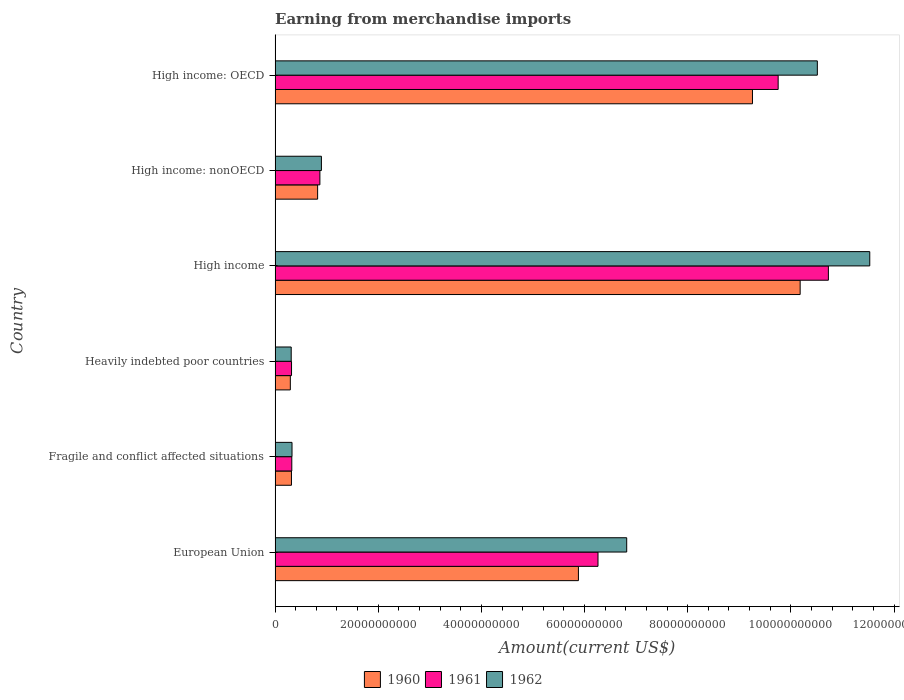How many groups of bars are there?
Give a very brief answer. 6. How many bars are there on the 4th tick from the top?
Make the answer very short. 3. What is the amount earned from merchandise imports in 1960 in European Union?
Your answer should be compact. 5.88e+1. Across all countries, what is the maximum amount earned from merchandise imports in 1960?
Keep it short and to the point. 1.02e+11. Across all countries, what is the minimum amount earned from merchandise imports in 1960?
Ensure brevity in your answer.  2.96e+09. In which country was the amount earned from merchandise imports in 1962 minimum?
Ensure brevity in your answer.  Heavily indebted poor countries. What is the total amount earned from merchandise imports in 1962 in the graph?
Give a very brief answer. 3.04e+11. What is the difference between the amount earned from merchandise imports in 1961 in Fragile and conflict affected situations and that in High income: OECD?
Provide a succinct answer. -9.43e+1. What is the difference between the amount earned from merchandise imports in 1962 in European Union and the amount earned from merchandise imports in 1960 in Fragile and conflict affected situations?
Keep it short and to the point. 6.50e+1. What is the average amount earned from merchandise imports in 1962 per country?
Provide a succinct answer. 5.07e+1. What is the difference between the amount earned from merchandise imports in 1962 and amount earned from merchandise imports in 1961 in Heavily indebted poor countries?
Offer a terse response. -6.38e+07. In how many countries, is the amount earned from merchandise imports in 1960 greater than 20000000000 US$?
Offer a terse response. 3. What is the ratio of the amount earned from merchandise imports in 1960 in European Union to that in High income: OECD?
Provide a succinct answer. 0.64. Is the difference between the amount earned from merchandise imports in 1962 in High income and High income: nonOECD greater than the difference between the amount earned from merchandise imports in 1961 in High income and High income: nonOECD?
Your answer should be compact. Yes. What is the difference between the highest and the second highest amount earned from merchandise imports in 1961?
Give a very brief answer. 9.74e+09. What is the difference between the highest and the lowest amount earned from merchandise imports in 1960?
Provide a short and direct response. 9.88e+1. What does the 1st bar from the top in Fragile and conflict affected situations represents?
Provide a short and direct response. 1962. How many bars are there?
Offer a terse response. 18. Does the graph contain any zero values?
Your response must be concise. No. Does the graph contain grids?
Keep it short and to the point. No. Where does the legend appear in the graph?
Make the answer very short. Bottom center. How are the legend labels stacked?
Provide a short and direct response. Horizontal. What is the title of the graph?
Make the answer very short. Earning from merchandise imports. What is the label or title of the X-axis?
Make the answer very short. Amount(current US$). What is the Amount(current US$) of 1960 in European Union?
Keep it short and to the point. 5.88e+1. What is the Amount(current US$) in 1961 in European Union?
Your answer should be very brief. 6.26e+1. What is the Amount(current US$) in 1962 in European Union?
Your answer should be very brief. 6.82e+1. What is the Amount(current US$) of 1960 in Fragile and conflict affected situations?
Give a very brief answer. 3.17e+09. What is the Amount(current US$) of 1961 in Fragile and conflict affected situations?
Your answer should be very brief. 3.24e+09. What is the Amount(current US$) in 1962 in Fragile and conflict affected situations?
Keep it short and to the point. 3.28e+09. What is the Amount(current US$) of 1960 in Heavily indebted poor countries?
Your answer should be very brief. 2.96e+09. What is the Amount(current US$) in 1961 in Heavily indebted poor countries?
Make the answer very short. 3.19e+09. What is the Amount(current US$) in 1962 in Heavily indebted poor countries?
Ensure brevity in your answer.  3.13e+09. What is the Amount(current US$) of 1960 in High income?
Your answer should be very brief. 1.02e+11. What is the Amount(current US$) in 1961 in High income?
Your response must be concise. 1.07e+11. What is the Amount(current US$) in 1962 in High income?
Ensure brevity in your answer.  1.15e+11. What is the Amount(current US$) of 1960 in High income: nonOECD?
Offer a terse response. 8.25e+09. What is the Amount(current US$) in 1961 in High income: nonOECD?
Offer a very short reply. 8.69e+09. What is the Amount(current US$) of 1962 in High income: nonOECD?
Your response must be concise. 8.98e+09. What is the Amount(current US$) in 1960 in High income: OECD?
Your response must be concise. 9.26e+1. What is the Amount(current US$) of 1961 in High income: OECD?
Offer a very short reply. 9.75e+1. What is the Amount(current US$) in 1962 in High income: OECD?
Give a very brief answer. 1.05e+11. Across all countries, what is the maximum Amount(current US$) of 1960?
Offer a very short reply. 1.02e+11. Across all countries, what is the maximum Amount(current US$) of 1961?
Offer a terse response. 1.07e+11. Across all countries, what is the maximum Amount(current US$) in 1962?
Ensure brevity in your answer.  1.15e+11. Across all countries, what is the minimum Amount(current US$) of 1960?
Ensure brevity in your answer.  2.96e+09. Across all countries, what is the minimum Amount(current US$) of 1961?
Keep it short and to the point. 3.19e+09. Across all countries, what is the minimum Amount(current US$) of 1962?
Your answer should be very brief. 3.13e+09. What is the total Amount(current US$) in 1960 in the graph?
Offer a terse response. 2.68e+11. What is the total Amount(current US$) of 1961 in the graph?
Provide a short and direct response. 2.83e+11. What is the total Amount(current US$) in 1962 in the graph?
Offer a terse response. 3.04e+11. What is the difference between the Amount(current US$) in 1960 in European Union and that in Fragile and conflict affected situations?
Make the answer very short. 5.56e+1. What is the difference between the Amount(current US$) of 1961 in European Union and that in Fragile and conflict affected situations?
Provide a succinct answer. 5.94e+1. What is the difference between the Amount(current US$) in 1962 in European Union and that in Fragile and conflict affected situations?
Your answer should be compact. 6.49e+1. What is the difference between the Amount(current US$) in 1960 in European Union and that in Heavily indebted poor countries?
Provide a short and direct response. 5.59e+1. What is the difference between the Amount(current US$) in 1961 in European Union and that in Heavily indebted poor countries?
Provide a short and direct response. 5.94e+1. What is the difference between the Amount(current US$) in 1962 in European Union and that in Heavily indebted poor countries?
Offer a terse response. 6.50e+1. What is the difference between the Amount(current US$) in 1960 in European Union and that in High income?
Provide a short and direct response. -4.30e+1. What is the difference between the Amount(current US$) of 1961 in European Union and that in High income?
Keep it short and to the point. -4.47e+1. What is the difference between the Amount(current US$) in 1962 in European Union and that in High income?
Offer a very short reply. -4.71e+1. What is the difference between the Amount(current US$) of 1960 in European Union and that in High income: nonOECD?
Your response must be concise. 5.06e+1. What is the difference between the Amount(current US$) in 1961 in European Union and that in High income: nonOECD?
Give a very brief answer. 5.39e+1. What is the difference between the Amount(current US$) in 1962 in European Union and that in High income: nonOECD?
Offer a terse response. 5.92e+1. What is the difference between the Amount(current US$) in 1960 in European Union and that in High income: OECD?
Make the answer very short. -3.37e+1. What is the difference between the Amount(current US$) in 1961 in European Union and that in High income: OECD?
Provide a succinct answer. -3.49e+1. What is the difference between the Amount(current US$) of 1962 in European Union and that in High income: OECD?
Your response must be concise. -3.70e+1. What is the difference between the Amount(current US$) of 1960 in Fragile and conflict affected situations and that in Heavily indebted poor countries?
Offer a very short reply. 2.18e+08. What is the difference between the Amount(current US$) in 1961 in Fragile and conflict affected situations and that in Heavily indebted poor countries?
Your answer should be very brief. 4.90e+07. What is the difference between the Amount(current US$) in 1962 in Fragile and conflict affected situations and that in Heavily indebted poor countries?
Make the answer very short. 1.55e+08. What is the difference between the Amount(current US$) in 1960 in Fragile and conflict affected situations and that in High income?
Provide a succinct answer. -9.86e+1. What is the difference between the Amount(current US$) in 1961 in Fragile and conflict affected situations and that in High income?
Your answer should be very brief. -1.04e+11. What is the difference between the Amount(current US$) in 1962 in Fragile and conflict affected situations and that in High income?
Offer a terse response. -1.12e+11. What is the difference between the Amount(current US$) of 1960 in Fragile and conflict affected situations and that in High income: nonOECD?
Provide a short and direct response. -5.08e+09. What is the difference between the Amount(current US$) in 1961 in Fragile and conflict affected situations and that in High income: nonOECD?
Ensure brevity in your answer.  -5.45e+09. What is the difference between the Amount(current US$) of 1962 in Fragile and conflict affected situations and that in High income: nonOECD?
Your answer should be very brief. -5.70e+09. What is the difference between the Amount(current US$) of 1960 in Fragile and conflict affected situations and that in High income: OECD?
Ensure brevity in your answer.  -8.94e+1. What is the difference between the Amount(current US$) in 1961 in Fragile and conflict affected situations and that in High income: OECD?
Give a very brief answer. -9.43e+1. What is the difference between the Amount(current US$) of 1962 in Fragile and conflict affected situations and that in High income: OECD?
Offer a terse response. -1.02e+11. What is the difference between the Amount(current US$) of 1960 in Heavily indebted poor countries and that in High income?
Give a very brief answer. -9.88e+1. What is the difference between the Amount(current US$) of 1961 in Heavily indebted poor countries and that in High income?
Offer a very short reply. -1.04e+11. What is the difference between the Amount(current US$) of 1962 in Heavily indebted poor countries and that in High income?
Ensure brevity in your answer.  -1.12e+11. What is the difference between the Amount(current US$) in 1960 in Heavily indebted poor countries and that in High income: nonOECD?
Give a very brief answer. -5.29e+09. What is the difference between the Amount(current US$) of 1961 in Heavily indebted poor countries and that in High income: nonOECD?
Ensure brevity in your answer.  -5.50e+09. What is the difference between the Amount(current US$) of 1962 in Heavily indebted poor countries and that in High income: nonOECD?
Provide a short and direct response. -5.85e+09. What is the difference between the Amount(current US$) of 1960 in Heavily indebted poor countries and that in High income: OECD?
Offer a very short reply. -8.96e+1. What is the difference between the Amount(current US$) of 1961 in Heavily indebted poor countries and that in High income: OECD?
Make the answer very short. -9.43e+1. What is the difference between the Amount(current US$) in 1962 in Heavily indebted poor countries and that in High income: OECD?
Your response must be concise. -1.02e+11. What is the difference between the Amount(current US$) in 1960 in High income and that in High income: nonOECD?
Offer a very short reply. 9.35e+1. What is the difference between the Amount(current US$) in 1961 in High income and that in High income: nonOECD?
Your answer should be compact. 9.86e+1. What is the difference between the Amount(current US$) of 1962 in High income and that in High income: nonOECD?
Make the answer very short. 1.06e+11. What is the difference between the Amount(current US$) of 1960 in High income and that in High income: OECD?
Offer a very short reply. 9.24e+09. What is the difference between the Amount(current US$) in 1961 in High income and that in High income: OECD?
Give a very brief answer. 9.74e+09. What is the difference between the Amount(current US$) of 1962 in High income and that in High income: OECD?
Your answer should be compact. 1.02e+1. What is the difference between the Amount(current US$) in 1960 in High income: nonOECD and that in High income: OECD?
Provide a succinct answer. -8.43e+1. What is the difference between the Amount(current US$) in 1961 in High income: nonOECD and that in High income: OECD?
Provide a succinct answer. -8.88e+1. What is the difference between the Amount(current US$) of 1962 in High income: nonOECD and that in High income: OECD?
Offer a very short reply. -9.61e+1. What is the difference between the Amount(current US$) in 1960 in European Union and the Amount(current US$) in 1961 in Fragile and conflict affected situations?
Keep it short and to the point. 5.56e+1. What is the difference between the Amount(current US$) in 1960 in European Union and the Amount(current US$) in 1962 in Fragile and conflict affected situations?
Your response must be concise. 5.55e+1. What is the difference between the Amount(current US$) in 1961 in European Union and the Amount(current US$) in 1962 in Fragile and conflict affected situations?
Offer a terse response. 5.93e+1. What is the difference between the Amount(current US$) of 1960 in European Union and the Amount(current US$) of 1961 in Heavily indebted poor countries?
Provide a short and direct response. 5.56e+1. What is the difference between the Amount(current US$) in 1960 in European Union and the Amount(current US$) in 1962 in Heavily indebted poor countries?
Provide a short and direct response. 5.57e+1. What is the difference between the Amount(current US$) of 1961 in European Union and the Amount(current US$) of 1962 in Heavily indebted poor countries?
Give a very brief answer. 5.95e+1. What is the difference between the Amount(current US$) in 1960 in European Union and the Amount(current US$) in 1961 in High income?
Offer a very short reply. -4.85e+1. What is the difference between the Amount(current US$) in 1960 in European Union and the Amount(current US$) in 1962 in High income?
Offer a terse response. -5.65e+1. What is the difference between the Amount(current US$) in 1961 in European Union and the Amount(current US$) in 1962 in High income?
Your answer should be compact. -5.27e+1. What is the difference between the Amount(current US$) of 1960 in European Union and the Amount(current US$) of 1961 in High income: nonOECD?
Your response must be concise. 5.01e+1. What is the difference between the Amount(current US$) of 1960 in European Union and the Amount(current US$) of 1962 in High income: nonOECD?
Provide a succinct answer. 4.98e+1. What is the difference between the Amount(current US$) in 1961 in European Union and the Amount(current US$) in 1962 in High income: nonOECD?
Your answer should be compact. 5.36e+1. What is the difference between the Amount(current US$) of 1960 in European Union and the Amount(current US$) of 1961 in High income: OECD?
Make the answer very short. -3.87e+1. What is the difference between the Amount(current US$) of 1960 in European Union and the Amount(current US$) of 1962 in High income: OECD?
Provide a short and direct response. -4.63e+1. What is the difference between the Amount(current US$) of 1961 in European Union and the Amount(current US$) of 1962 in High income: OECD?
Your response must be concise. -4.25e+1. What is the difference between the Amount(current US$) of 1960 in Fragile and conflict affected situations and the Amount(current US$) of 1961 in Heavily indebted poor countries?
Give a very brief answer. -1.74e+07. What is the difference between the Amount(current US$) of 1960 in Fragile and conflict affected situations and the Amount(current US$) of 1962 in Heavily indebted poor countries?
Offer a terse response. 4.64e+07. What is the difference between the Amount(current US$) in 1961 in Fragile and conflict affected situations and the Amount(current US$) in 1962 in Heavily indebted poor countries?
Offer a very short reply. 1.13e+08. What is the difference between the Amount(current US$) in 1960 in Fragile and conflict affected situations and the Amount(current US$) in 1961 in High income?
Your answer should be very brief. -1.04e+11. What is the difference between the Amount(current US$) of 1960 in Fragile and conflict affected situations and the Amount(current US$) of 1962 in High income?
Offer a very short reply. -1.12e+11. What is the difference between the Amount(current US$) in 1961 in Fragile and conflict affected situations and the Amount(current US$) in 1962 in High income?
Provide a short and direct response. -1.12e+11. What is the difference between the Amount(current US$) in 1960 in Fragile and conflict affected situations and the Amount(current US$) in 1961 in High income: nonOECD?
Offer a very short reply. -5.51e+09. What is the difference between the Amount(current US$) in 1960 in Fragile and conflict affected situations and the Amount(current US$) in 1962 in High income: nonOECD?
Make the answer very short. -5.81e+09. What is the difference between the Amount(current US$) of 1961 in Fragile and conflict affected situations and the Amount(current US$) of 1962 in High income: nonOECD?
Offer a very short reply. -5.74e+09. What is the difference between the Amount(current US$) of 1960 in Fragile and conflict affected situations and the Amount(current US$) of 1961 in High income: OECD?
Make the answer very short. -9.44e+1. What is the difference between the Amount(current US$) in 1960 in Fragile and conflict affected situations and the Amount(current US$) in 1962 in High income: OECD?
Ensure brevity in your answer.  -1.02e+11. What is the difference between the Amount(current US$) in 1961 in Fragile and conflict affected situations and the Amount(current US$) in 1962 in High income: OECD?
Your answer should be compact. -1.02e+11. What is the difference between the Amount(current US$) of 1960 in Heavily indebted poor countries and the Amount(current US$) of 1961 in High income?
Give a very brief answer. -1.04e+11. What is the difference between the Amount(current US$) in 1960 in Heavily indebted poor countries and the Amount(current US$) in 1962 in High income?
Your answer should be very brief. -1.12e+11. What is the difference between the Amount(current US$) of 1961 in Heavily indebted poor countries and the Amount(current US$) of 1962 in High income?
Your answer should be very brief. -1.12e+11. What is the difference between the Amount(current US$) of 1960 in Heavily indebted poor countries and the Amount(current US$) of 1961 in High income: nonOECD?
Give a very brief answer. -5.73e+09. What is the difference between the Amount(current US$) in 1960 in Heavily indebted poor countries and the Amount(current US$) in 1962 in High income: nonOECD?
Offer a terse response. -6.03e+09. What is the difference between the Amount(current US$) of 1961 in Heavily indebted poor countries and the Amount(current US$) of 1962 in High income: nonOECD?
Give a very brief answer. -5.79e+09. What is the difference between the Amount(current US$) of 1960 in Heavily indebted poor countries and the Amount(current US$) of 1961 in High income: OECD?
Your answer should be compact. -9.46e+1. What is the difference between the Amount(current US$) of 1960 in Heavily indebted poor countries and the Amount(current US$) of 1962 in High income: OECD?
Your response must be concise. -1.02e+11. What is the difference between the Amount(current US$) of 1961 in Heavily indebted poor countries and the Amount(current US$) of 1962 in High income: OECD?
Your answer should be very brief. -1.02e+11. What is the difference between the Amount(current US$) of 1960 in High income and the Amount(current US$) of 1961 in High income: nonOECD?
Keep it short and to the point. 9.31e+1. What is the difference between the Amount(current US$) of 1960 in High income and the Amount(current US$) of 1962 in High income: nonOECD?
Your response must be concise. 9.28e+1. What is the difference between the Amount(current US$) of 1961 in High income and the Amount(current US$) of 1962 in High income: nonOECD?
Make the answer very short. 9.83e+1. What is the difference between the Amount(current US$) of 1960 in High income and the Amount(current US$) of 1961 in High income: OECD?
Keep it short and to the point. 4.26e+09. What is the difference between the Amount(current US$) in 1960 in High income and the Amount(current US$) in 1962 in High income: OECD?
Offer a terse response. -3.33e+09. What is the difference between the Amount(current US$) of 1961 in High income and the Amount(current US$) of 1962 in High income: OECD?
Make the answer very short. 2.14e+09. What is the difference between the Amount(current US$) of 1960 in High income: nonOECD and the Amount(current US$) of 1961 in High income: OECD?
Ensure brevity in your answer.  -8.93e+1. What is the difference between the Amount(current US$) in 1960 in High income: nonOECD and the Amount(current US$) in 1962 in High income: OECD?
Offer a terse response. -9.69e+1. What is the difference between the Amount(current US$) of 1961 in High income: nonOECD and the Amount(current US$) of 1962 in High income: OECD?
Your answer should be compact. -9.64e+1. What is the average Amount(current US$) in 1960 per country?
Provide a succinct answer. 4.46e+1. What is the average Amount(current US$) of 1961 per country?
Make the answer very short. 4.71e+1. What is the average Amount(current US$) of 1962 per country?
Ensure brevity in your answer.  5.07e+1. What is the difference between the Amount(current US$) of 1960 and Amount(current US$) of 1961 in European Union?
Your answer should be compact. -3.80e+09. What is the difference between the Amount(current US$) of 1960 and Amount(current US$) of 1962 in European Union?
Your answer should be compact. -9.36e+09. What is the difference between the Amount(current US$) of 1961 and Amount(current US$) of 1962 in European Union?
Your answer should be very brief. -5.56e+09. What is the difference between the Amount(current US$) in 1960 and Amount(current US$) in 1961 in Fragile and conflict affected situations?
Make the answer very short. -6.64e+07. What is the difference between the Amount(current US$) in 1960 and Amount(current US$) in 1962 in Fragile and conflict affected situations?
Your answer should be compact. -1.09e+08. What is the difference between the Amount(current US$) of 1961 and Amount(current US$) of 1962 in Fragile and conflict affected situations?
Offer a very short reply. -4.24e+07. What is the difference between the Amount(current US$) of 1960 and Amount(current US$) of 1961 in Heavily indebted poor countries?
Give a very brief answer. -2.35e+08. What is the difference between the Amount(current US$) of 1960 and Amount(current US$) of 1962 in Heavily indebted poor countries?
Offer a very short reply. -1.71e+08. What is the difference between the Amount(current US$) in 1961 and Amount(current US$) in 1962 in Heavily indebted poor countries?
Your response must be concise. 6.38e+07. What is the difference between the Amount(current US$) in 1960 and Amount(current US$) in 1961 in High income?
Your answer should be very brief. -5.47e+09. What is the difference between the Amount(current US$) in 1960 and Amount(current US$) in 1962 in High income?
Your response must be concise. -1.35e+1. What is the difference between the Amount(current US$) of 1961 and Amount(current US$) of 1962 in High income?
Ensure brevity in your answer.  -8.02e+09. What is the difference between the Amount(current US$) in 1960 and Amount(current US$) in 1961 in High income: nonOECD?
Keep it short and to the point. -4.38e+08. What is the difference between the Amount(current US$) of 1960 and Amount(current US$) of 1962 in High income: nonOECD?
Give a very brief answer. -7.32e+08. What is the difference between the Amount(current US$) of 1961 and Amount(current US$) of 1962 in High income: nonOECD?
Provide a short and direct response. -2.93e+08. What is the difference between the Amount(current US$) in 1960 and Amount(current US$) in 1961 in High income: OECD?
Your response must be concise. -4.98e+09. What is the difference between the Amount(current US$) in 1960 and Amount(current US$) in 1962 in High income: OECD?
Provide a succinct answer. -1.26e+1. What is the difference between the Amount(current US$) of 1961 and Amount(current US$) of 1962 in High income: OECD?
Keep it short and to the point. -7.59e+09. What is the ratio of the Amount(current US$) of 1960 in European Union to that in Fragile and conflict affected situations?
Your response must be concise. 18.53. What is the ratio of the Amount(current US$) of 1961 in European Union to that in Fragile and conflict affected situations?
Offer a very short reply. 19.32. What is the ratio of the Amount(current US$) of 1962 in European Union to that in Fragile and conflict affected situations?
Give a very brief answer. 20.77. What is the ratio of the Amount(current US$) of 1960 in European Union to that in Heavily indebted poor countries?
Your response must be concise. 19.9. What is the ratio of the Amount(current US$) of 1961 in European Union to that in Heavily indebted poor countries?
Offer a terse response. 19.62. What is the ratio of the Amount(current US$) in 1962 in European Union to that in Heavily indebted poor countries?
Offer a very short reply. 21.8. What is the ratio of the Amount(current US$) in 1960 in European Union to that in High income?
Make the answer very short. 0.58. What is the ratio of the Amount(current US$) in 1961 in European Union to that in High income?
Give a very brief answer. 0.58. What is the ratio of the Amount(current US$) in 1962 in European Union to that in High income?
Your response must be concise. 0.59. What is the ratio of the Amount(current US$) of 1960 in European Union to that in High income: nonOECD?
Keep it short and to the point. 7.13. What is the ratio of the Amount(current US$) in 1961 in European Union to that in High income: nonOECD?
Offer a terse response. 7.21. What is the ratio of the Amount(current US$) in 1962 in European Union to that in High income: nonOECD?
Your answer should be very brief. 7.59. What is the ratio of the Amount(current US$) in 1960 in European Union to that in High income: OECD?
Provide a succinct answer. 0.64. What is the ratio of the Amount(current US$) of 1961 in European Union to that in High income: OECD?
Offer a very short reply. 0.64. What is the ratio of the Amount(current US$) in 1962 in European Union to that in High income: OECD?
Provide a short and direct response. 0.65. What is the ratio of the Amount(current US$) in 1960 in Fragile and conflict affected situations to that in Heavily indebted poor countries?
Your response must be concise. 1.07. What is the ratio of the Amount(current US$) in 1961 in Fragile and conflict affected situations to that in Heavily indebted poor countries?
Provide a short and direct response. 1.02. What is the ratio of the Amount(current US$) in 1962 in Fragile and conflict affected situations to that in Heavily indebted poor countries?
Your answer should be very brief. 1.05. What is the ratio of the Amount(current US$) in 1960 in Fragile and conflict affected situations to that in High income?
Offer a terse response. 0.03. What is the ratio of the Amount(current US$) in 1961 in Fragile and conflict affected situations to that in High income?
Provide a short and direct response. 0.03. What is the ratio of the Amount(current US$) in 1962 in Fragile and conflict affected situations to that in High income?
Offer a terse response. 0.03. What is the ratio of the Amount(current US$) in 1960 in Fragile and conflict affected situations to that in High income: nonOECD?
Make the answer very short. 0.38. What is the ratio of the Amount(current US$) in 1961 in Fragile and conflict affected situations to that in High income: nonOECD?
Keep it short and to the point. 0.37. What is the ratio of the Amount(current US$) of 1962 in Fragile and conflict affected situations to that in High income: nonOECD?
Keep it short and to the point. 0.37. What is the ratio of the Amount(current US$) of 1960 in Fragile and conflict affected situations to that in High income: OECD?
Ensure brevity in your answer.  0.03. What is the ratio of the Amount(current US$) in 1961 in Fragile and conflict affected situations to that in High income: OECD?
Provide a short and direct response. 0.03. What is the ratio of the Amount(current US$) in 1962 in Fragile and conflict affected situations to that in High income: OECD?
Ensure brevity in your answer.  0.03. What is the ratio of the Amount(current US$) of 1960 in Heavily indebted poor countries to that in High income?
Keep it short and to the point. 0.03. What is the ratio of the Amount(current US$) of 1961 in Heavily indebted poor countries to that in High income?
Give a very brief answer. 0.03. What is the ratio of the Amount(current US$) of 1962 in Heavily indebted poor countries to that in High income?
Give a very brief answer. 0.03. What is the ratio of the Amount(current US$) of 1960 in Heavily indebted poor countries to that in High income: nonOECD?
Offer a very short reply. 0.36. What is the ratio of the Amount(current US$) of 1961 in Heavily indebted poor countries to that in High income: nonOECD?
Offer a very short reply. 0.37. What is the ratio of the Amount(current US$) in 1962 in Heavily indebted poor countries to that in High income: nonOECD?
Provide a short and direct response. 0.35. What is the ratio of the Amount(current US$) in 1960 in Heavily indebted poor countries to that in High income: OECD?
Your answer should be compact. 0.03. What is the ratio of the Amount(current US$) of 1961 in Heavily indebted poor countries to that in High income: OECD?
Keep it short and to the point. 0.03. What is the ratio of the Amount(current US$) of 1962 in Heavily indebted poor countries to that in High income: OECD?
Provide a short and direct response. 0.03. What is the ratio of the Amount(current US$) of 1960 in High income to that in High income: nonOECD?
Your answer should be compact. 12.34. What is the ratio of the Amount(current US$) of 1961 in High income to that in High income: nonOECD?
Provide a short and direct response. 12.35. What is the ratio of the Amount(current US$) in 1962 in High income to that in High income: nonOECD?
Provide a succinct answer. 12.84. What is the ratio of the Amount(current US$) in 1960 in High income to that in High income: OECD?
Your response must be concise. 1.1. What is the ratio of the Amount(current US$) of 1961 in High income to that in High income: OECD?
Offer a very short reply. 1.1. What is the ratio of the Amount(current US$) in 1962 in High income to that in High income: OECD?
Keep it short and to the point. 1.1. What is the ratio of the Amount(current US$) in 1960 in High income: nonOECD to that in High income: OECD?
Keep it short and to the point. 0.09. What is the ratio of the Amount(current US$) in 1961 in High income: nonOECD to that in High income: OECD?
Your answer should be compact. 0.09. What is the ratio of the Amount(current US$) in 1962 in High income: nonOECD to that in High income: OECD?
Offer a terse response. 0.09. What is the difference between the highest and the second highest Amount(current US$) of 1960?
Your response must be concise. 9.24e+09. What is the difference between the highest and the second highest Amount(current US$) in 1961?
Make the answer very short. 9.74e+09. What is the difference between the highest and the second highest Amount(current US$) in 1962?
Provide a succinct answer. 1.02e+1. What is the difference between the highest and the lowest Amount(current US$) in 1960?
Provide a short and direct response. 9.88e+1. What is the difference between the highest and the lowest Amount(current US$) of 1961?
Offer a terse response. 1.04e+11. What is the difference between the highest and the lowest Amount(current US$) of 1962?
Give a very brief answer. 1.12e+11. 